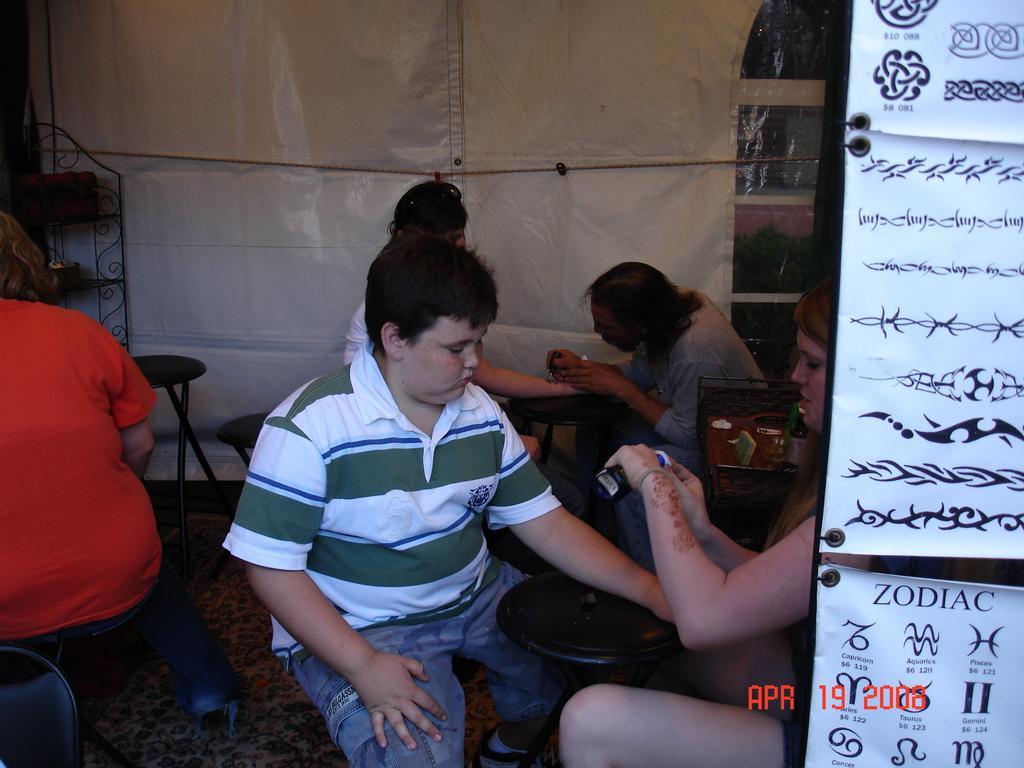Please provide a concise description of this image. In this image we can see two people sitting in the opposite direction. There is a stool in between them. 